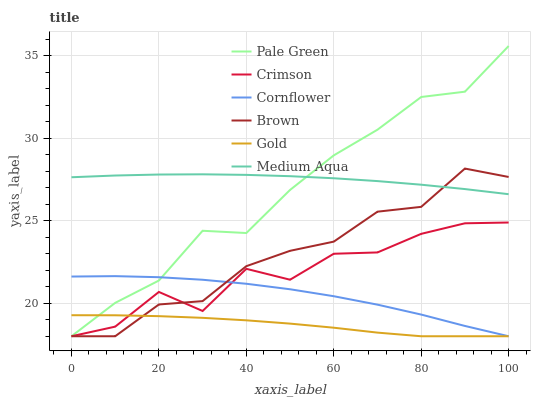Does Gold have the minimum area under the curve?
Answer yes or no. Yes. Does Medium Aqua have the maximum area under the curve?
Answer yes or no. Yes. Does Brown have the minimum area under the curve?
Answer yes or no. No. Does Brown have the maximum area under the curve?
Answer yes or no. No. Is Medium Aqua the smoothest?
Answer yes or no. Yes. Is Crimson the roughest?
Answer yes or no. Yes. Is Gold the smoothest?
Answer yes or no. No. Is Gold the roughest?
Answer yes or no. No. Does Cornflower have the lowest value?
Answer yes or no. Yes. Does Medium Aqua have the lowest value?
Answer yes or no. No. Does Pale Green have the highest value?
Answer yes or no. Yes. Does Brown have the highest value?
Answer yes or no. No. Is Crimson less than Medium Aqua?
Answer yes or no. Yes. Is Medium Aqua greater than Gold?
Answer yes or no. Yes. Does Gold intersect Cornflower?
Answer yes or no. Yes. Is Gold less than Cornflower?
Answer yes or no. No. Is Gold greater than Cornflower?
Answer yes or no. No. Does Crimson intersect Medium Aqua?
Answer yes or no. No. 